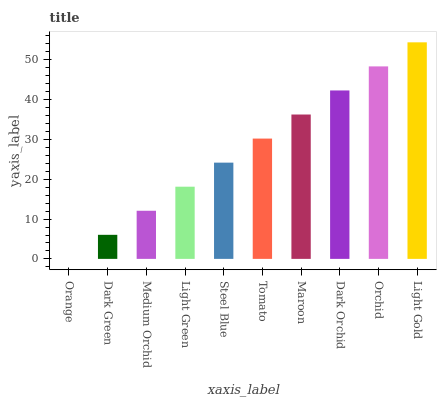Is Orange the minimum?
Answer yes or no. Yes. Is Light Gold the maximum?
Answer yes or no. Yes. Is Dark Green the minimum?
Answer yes or no. No. Is Dark Green the maximum?
Answer yes or no. No. Is Dark Green greater than Orange?
Answer yes or no. Yes. Is Orange less than Dark Green?
Answer yes or no. Yes. Is Orange greater than Dark Green?
Answer yes or no. No. Is Dark Green less than Orange?
Answer yes or no. No. Is Tomato the high median?
Answer yes or no. Yes. Is Steel Blue the low median?
Answer yes or no. Yes. Is Orange the high median?
Answer yes or no. No. Is Medium Orchid the low median?
Answer yes or no. No. 